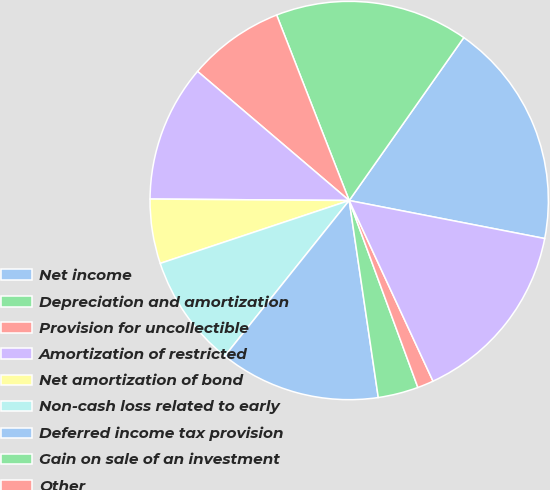<chart> <loc_0><loc_0><loc_500><loc_500><pie_chart><fcel>Net income<fcel>Depreciation and amortization<fcel>Provision for uncollectible<fcel>Amortization of restricted<fcel>Net amortization of bond<fcel>Non-cash loss related to early<fcel>Deferred income tax provision<fcel>Gain on sale of an investment<fcel>Other<fcel>Accounts receivable<nl><fcel>18.3%<fcel>15.69%<fcel>7.84%<fcel>11.11%<fcel>5.23%<fcel>9.15%<fcel>13.07%<fcel>3.27%<fcel>1.31%<fcel>15.03%<nl></chart> 